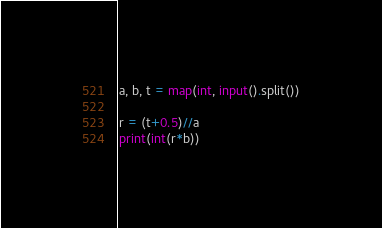Convert code to text. <code><loc_0><loc_0><loc_500><loc_500><_Python_>a, b, t = map(int, input().split())

r = (t+0.5)//a
print(int(r*b))</code> 